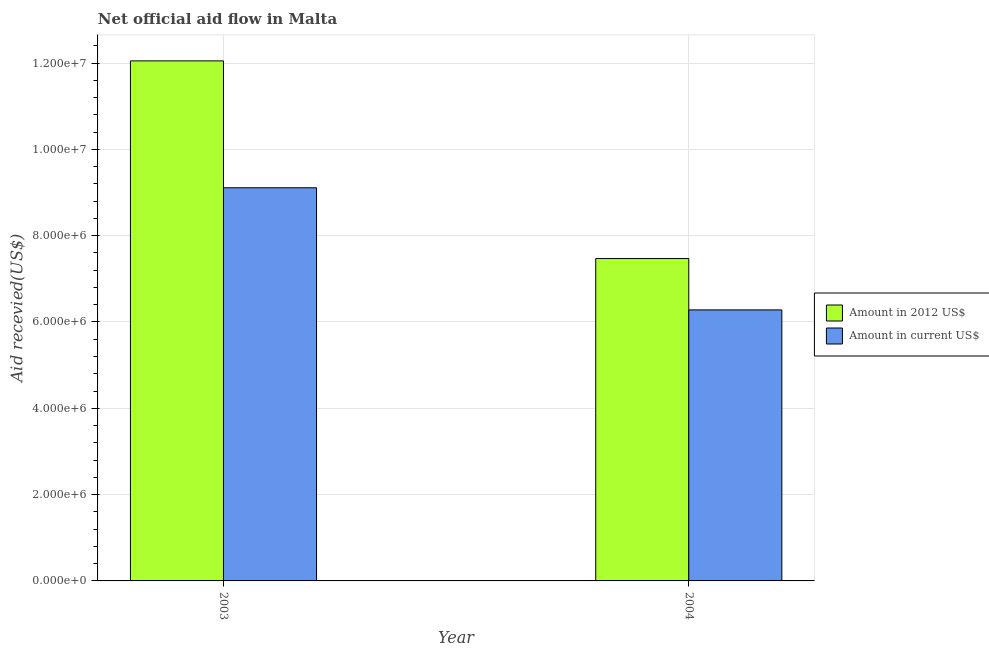How many different coloured bars are there?
Your answer should be very brief. 2. How many groups of bars are there?
Your answer should be compact. 2. Are the number of bars per tick equal to the number of legend labels?
Your response must be concise. Yes. Are the number of bars on each tick of the X-axis equal?
Your answer should be compact. Yes. How many bars are there on the 1st tick from the left?
Your answer should be very brief. 2. How many bars are there on the 2nd tick from the right?
Make the answer very short. 2. What is the label of the 1st group of bars from the left?
Ensure brevity in your answer.  2003. In how many cases, is the number of bars for a given year not equal to the number of legend labels?
Give a very brief answer. 0. What is the amount of aid received(expressed in us$) in 2003?
Give a very brief answer. 9.11e+06. Across all years, what is the maximum amount of aid received(expressed in 2012 us$)?
Give a very brief answer. 1.20e+07. Across all years, what is the minimum amount of aid received(expressed in 2012 us$)?
Provide a succinct answer. 7.47e+06. In which year was the amount of aid received(expressed in 2012 us$) minimum?
Ensure brevity in your answer.  2004. What is the total amount of aid received(expressed in 2012 us$) in the graph?
Your answer should be very brief. 1.95e+07. What is the difference between the amount of aid received(expressed in 2012 us$) in 2003 and that in 2004?
Make the answer very short. 4.58e+06. What is the difference between the amount of aid received(expressed in us$) in 2003 and the amount of aid received(expressed in 2012 us$) in 2004?
Offer a very short reply. 2.83e+06. What is the average amount of aid received(expressed in us$) per year?
Provide a succinct answer. 7.70e+06. In how many years, is the amount of aid received(expressed in us$) greater than 10800000 US$?
Provide a short and direct response. 0. What is the ratio of the amount of aid received(expressed in 2012 us$) in 2003 to that in 2004?
Provide a succinct answer. 1.61. Is the amount of aid received(expressed in us$) in 2003 less than that in 2004?
Your answer should be very brief. No. What does the 1st bar from the left in 2004 represents?
Your response must be concise. Amount in 2012 US$. What does the 1st bar from the right in 2003 represents?
Offer a very short reply. Amount in current US$. Are all the bars in the graph horizontal?
Offer a terse response. No. Does the graph contain grids?
Offer a very short reply. Yes. How many legend labels are there?
Keep it short and to the point. 2. What is the title of the graph?
Provide a succinct answer. Net official aid flow in Malta. Does "GDP per capita" appear as one of the legend labels in the graph?
Provide a short and direct response. No. What is the label or title of the X-axis?
Provide a succinct answer. Year. What is the label or title of the Y-axis?
Your response must be concise. Aid recevied(US$). What is the Aid recevied(US$) of Amount in 2012 US$ in 2003?
Keep it short and to the point. 1.20e+07. What is the Aid recevied(US$) of Amount in current US$ in 2003?
Provide a succinct answer. 9.11e+06. What is the Aid recevied(US$) in Amount in 2012 US$ in 2004?
Keep it short and to the point. 7.47e+06. What is the Aid recevied(US$) of Amount in current US$ in 2004?
Ensure brevity in your answer.  6.28e+06. Across all years, what is the maximum Aid recevied(US$) of Amount in 2012 US$?
Provide a succinct answer. 1.20e+07. Across all years, what is the maximum Aid recevied(US$) in Amount in current US$?
Your answer should be compact. 9.11e+06. Across all years, what is the minimum Aid recevied(US$) of Amount in 2012 US$?
Offer a very short reply. 7.47e+06. Across all years, what is the minimum Aid recevied(US$) of Amount in current US$?
Your answer should be very brief. 6.28e+06. What is the total Aid recevied(US$) of Amount in 2012 US$ in the graph?
Your answer should be very brief. 1.95e+07. What is the total Aid recevied(US$) in Amount in current US$ in the graph?
Your response must be concise. 1.54e+07. What is the difference between the Aid recevied(US$) in Amount in 2012 US$ in 2003 and that in 2004?
Offer a terse response. 4.58e+06. What is the difference between the Aid recevied(US$) of Amount in current US$ in 2003 and that in 2004?
Your response must be concise. 2.83e+06. What is the difference between the Aid recevied(US$) in Amount in 2012 US$ in 2003 and the Aid recevied(US$) in Amount in current US$ in 2004?
Ensure brevity in your answer.  5.77e+06. What is the average Aid recevied(US$) of Amount in 2012 US$ per year?
Keep it short and to the point. 9.76e+06. What is the average Aid recevied(US$) of Amount in current US$ per year?
Keep it short and to the point. 7.70e+06. In the year 2003, what is the difference between the Aid recevied(US$) in Amount in 2012 US$ and Aid recevied(US$) in Amount in current US$?
Your answer should be very brief. 2.94e+06. In the year 2004, what is the difference between the Aid recevied(US$) in Amount in 2012 US$ and Aid recevied(US$) in Amount in current US$?
Your response must be concise. 1.19e+06. What is the ratio of the Aid recevied(US$) in Amount in 2012 US$ in 2003 to that in 2004?
Offer a very short reply. 1.61. What is the ratio of the Aid recevied(US$) of Amount in current US$ in 2003 to that in 2004?
Provide a short and direct response. 1.45. What is the difference between the highest and the second highest Aid recevied(US$) of Amount in 2012 US$?
Offer a terse response. 4.58e+06. What is the difference between the highest and the second highest Aid recevied(US$) of Amount in current US$?
Make the answer very short. 2.83e+06. What is the difference between the highest and the lowest Aid recevied(US$) of Amount in 2012 US$?
Give a very brief answer. 4.58e+06. What is the difference between the highest and the lowest Aid recevied(US$) of Amount in current US$?
Offer a very short reply. 2.83e+06. 